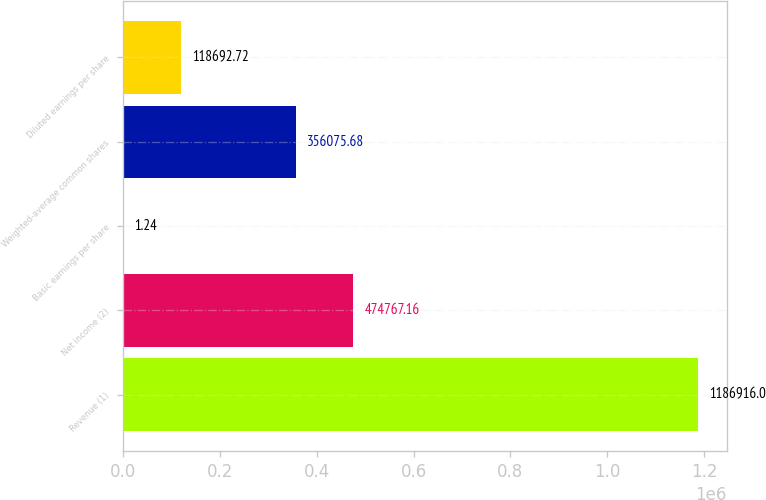<chart> <loc_0><loc_0><loc_500><loc_500><bar_chart><fcel>Revenue (1)<fcel>Net income (2)<fcel>Basic earnings per share<fcel>Weighted-average common shares<fcel>Diluted earnings per share<nl><fcel>1.18692e+06<fcel>474767<fcel>1.24<fcel>356076<fcel>118693<nl></chart> 